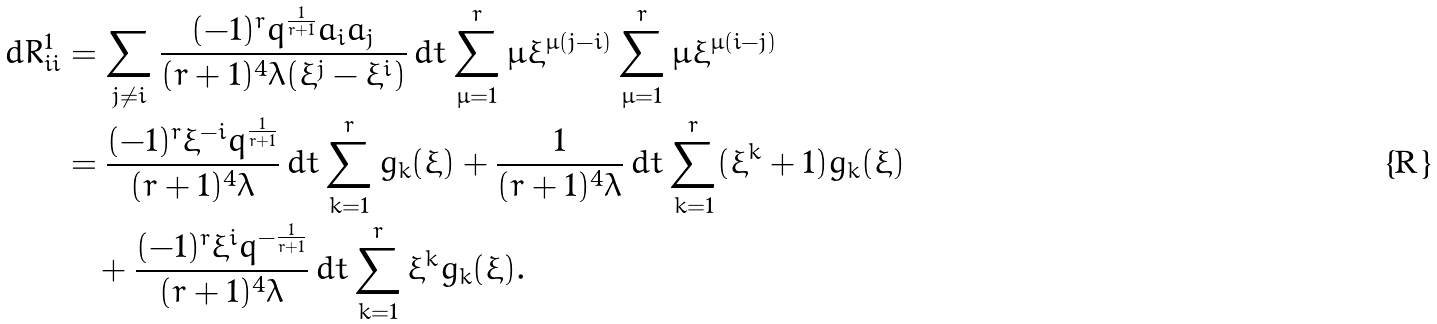Convert formula to latex. <formula><loc_0><loc_0><loc_500><loc_500>d R ^ { 1 } _ { i i } & = \sum _ { j \neq i } \frac { ( - 1 ) ^ { r } q ^ { \frac { 1 } { r + 1 } } a _ { i } a _ { j } } { ( r + 1 ) ^ { 4 } \lambda ( \xi ^ { j } - \xi ^ { i } ) } \, d t \sum _ { \mu = 1 } ^ { r } \mu \xi ^ { \mu ( j - i ) } \sum _ { \mu = 1 } ^ { r } \mu \xi ^ { \mu ( i - j ) } \\ & = \frac { ( - 1 ) ^ { r } \xi ^ { - i } q ^ { \frac { 1 } { r + 1 } } } { ( r + 1 ) ^ { 4 } \lambda } \, d t \sum _ { k = 1 } ^ { r } g _ { k } ( \xi ) + \frac { 1 } { ( r + 1 ) ^ { 4 } \lambda } \, d t \sum _ { k = 1 } ^ { r } ( \xi ^ { k } + 1 ) g _ { k } ( \xi ) \\ & \quad + \frac { ( - 1 ) ^ { r } \xi ^ { i } q ^ { - \frac { 1 } { r + 1 } } } { ( r + 1 ) ^ { 4 } \lambda } \, d t \sum _ { k = 1 } ^ { r } \xi ^ { k } g _ { k } ( \xi ) .</formula> 